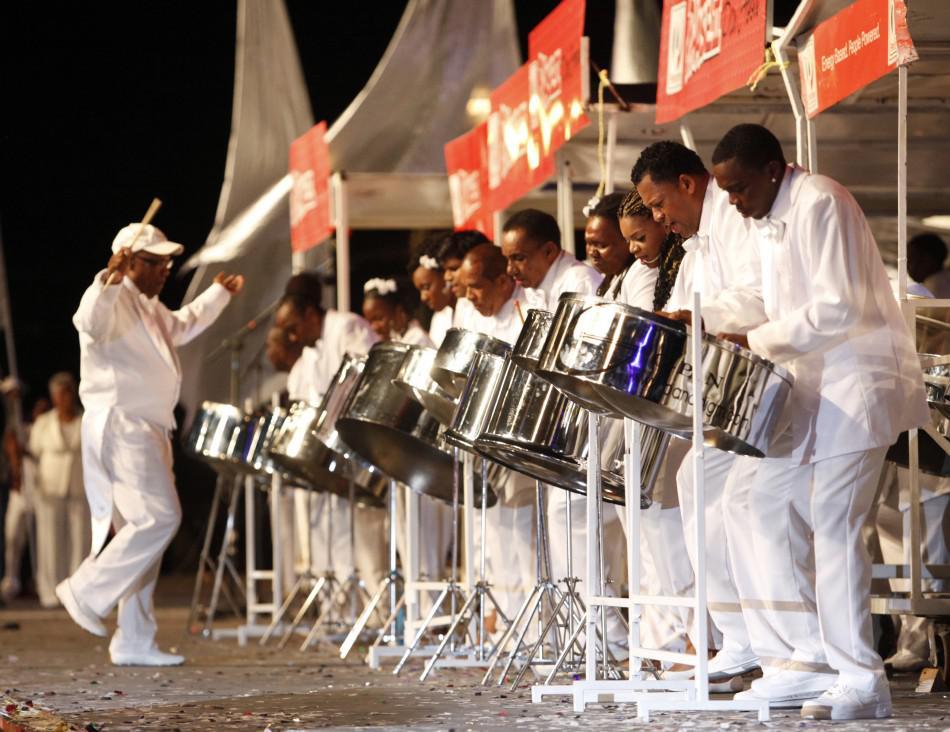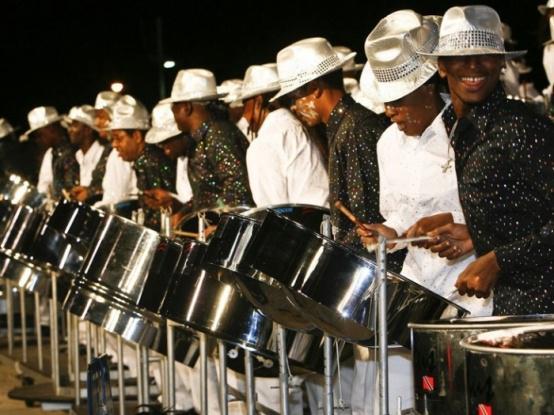The first image is the image on the left, the second image is the image on the right. For the images shown, is this caption "The right image shows a line of standing drummers in shiny fedora hats, with silver drums on stands in front of them." true? Answer yes or no. Yes. The first image is the image on the left, the second image is the image on the right. Analyze the images presented: Is the assertion "In one image, every musician is wearing a hat." valid? Answer yes or no. Yes. 